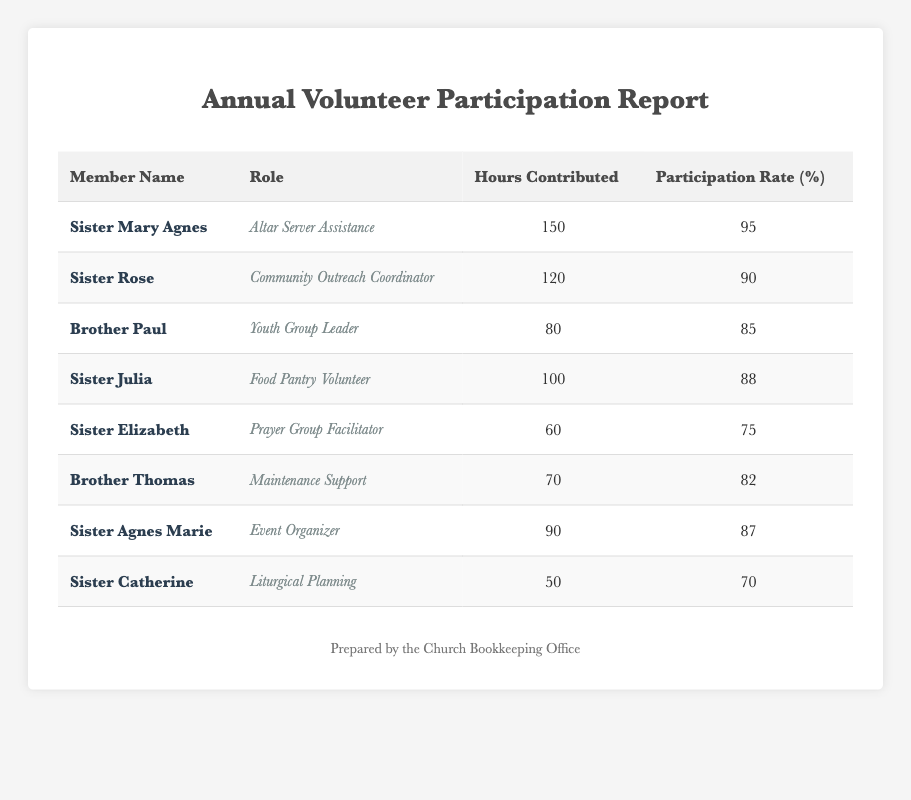What is the highest number of hours contributed by a volunteer? Sister Mary Agnes contributed the highest number of hours with 150 hours.
Answer: 150 What is Brother Paul's participation rate? Brother Paul's participation rate is 85%.
Answer: 85% Who contributed the least hours among the volunteers? Sister Catherine contributed the least hours with a total of 50.
Answer: 50 What is the average participation rate of all volunteers? To find the average, add all participation rates: 95 + 90 + 85 + 88 + 75 + 82 + 87 + 70 =  682. Then divide by the number of volunteers: 682/8 = 85.25.
Answer: 85.25 Is Sister Elizabeth's participation rate higher than 80%? Sister Elizabeth’s participation rate is 75%, which is not higher than 80%.
Answer: No How many volunteers contributed more than 80 hours? Three volunteers contributed more than 80 hours: Sister Mary Agnes (150), Sister Rose (120), and Sister Julia (100).
Answer: 3 What is the total number of hours contributed by all volunteers? Adding all hours: 150 + 120 + 80 + 100 + 60 + 70 + 90 + 50 = 720.
Answer: 720 Which role had the highest hours contributed by a volunteer? The role with the highest hours is "Altar Server Assistance," held by Sister Mary Agnes, who contributed 150 hours.
Answer: Altar Server Assistance Is there any volunteer with a participation rate of 70% or lower? Yes, Sister Elizabeth (75%) and Sister Catherine (70%) have participation rates of 70% or lower.
Answer: Yes 